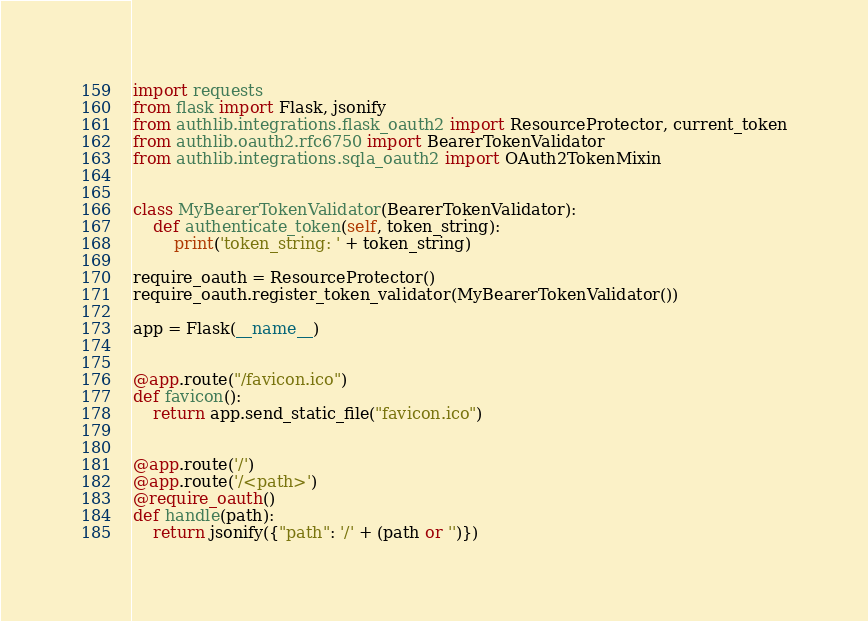<code> <loc_0><loc_0><loc_500><loc_500><_Python_>import requests
from flask import Flask, jsonify
from authlib.integrations.flask_oauth2 import ResourceProtector, current_token
from authlib.oauth2.rfc6750 import BearerTokenValidator
from authlib.integrations.sqla_oauth2 import OAuth2TokenMixin


class MyBearerTokenValidator(BearerTokenValidator):
    def authenticate_token(self, token_string):
        print('token_string: ' + token_string)

require_oauth = ResourceProtector()
require_oauth.register_token_validator(MyBearerTokenValidator())

app = Flask(__name__)


@app.route("/favicon.ico")
def favicon():
    return app.send_static_file("favicon.ico")


@app.route('/')
@app.route('/<path>')
@require_oauth()
def handle(path):
    return jsonify({"path": '/' + (path or '')})
</code> 